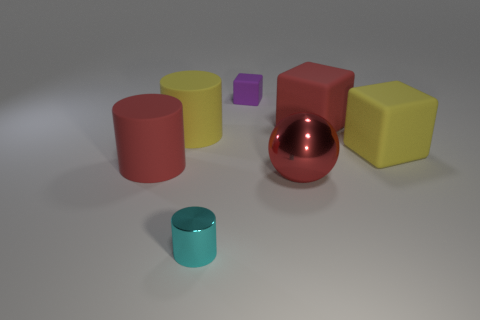Is the color of the metal object behind the small metallic cylinder the same as the tiny thing behind the red sphere?
Provide a short and direct response. No. What number of things are to the left of the ball and behind the big red metallic ball?
Ensure brevity in your answer.  3. What is the material of the large red ball?
Keep it short and to the point. Metal. The metal object that is the same size as the red matte block is what shape?
Make the answer very short. Sphere. Is the material of the cylinder that is in front of the red ball the same as the large red object that is to the left of the small purple object?
Provide a short and direct response. No. How many red rubber things are there?
Your answer should be compact. 2. What number of large things have the same shape as the tiny cyan shiny thing?
Your answer should be compact. 2. Is the large red metal object the same shape as the cyan metal object?
Offer a very short reply. No. The cyan object has what size?
Give a very brief answer. Small. How many gray metal cylinders have the same size as the yellow cylinder?
Your answer should be very brief. 0. 